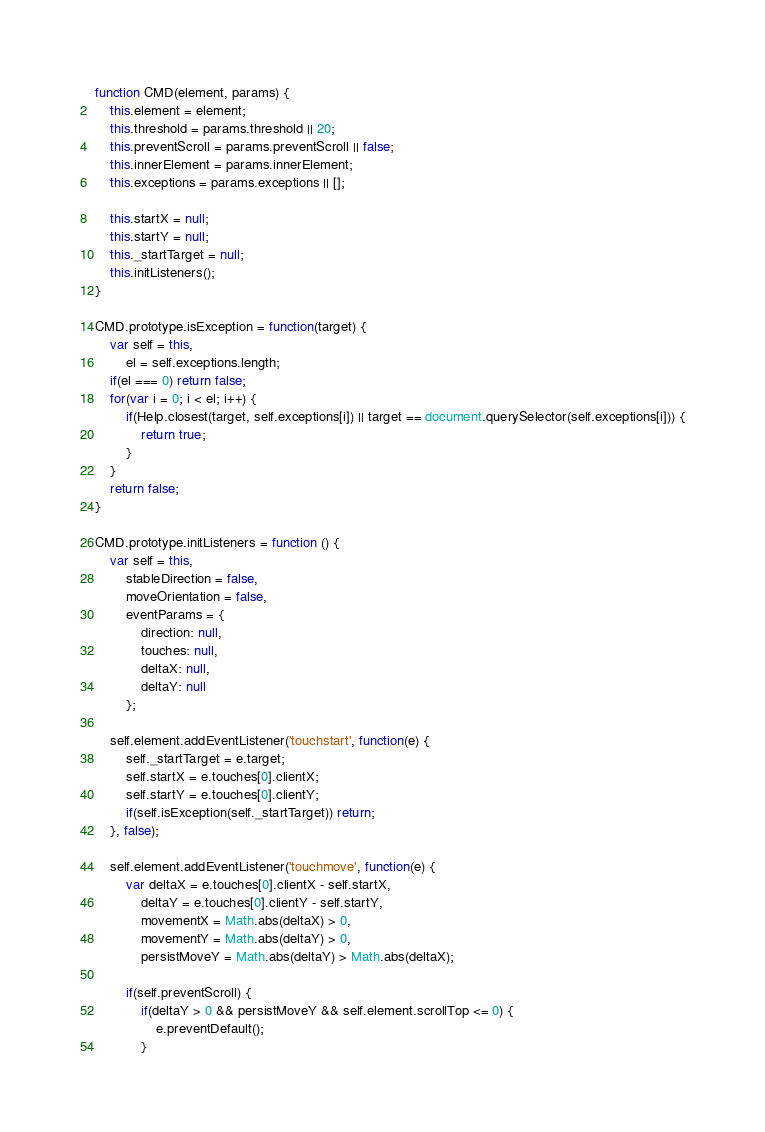<code> <loc_0><loc_0><loc_500><loc_500><_JavaScript_>function CMD(element, params) {
    this.element = element;
    this.threshold = params.threshold || 20;
    this.preventScroll = params.preventScroll || false;
    this.innerElement = params.innerElement;
    this.exceptions = params.exceptions || [];

    this.startX = null;
    this.startY = null;
    this._startTarget = null;
    this.initListeners();
}

CMD.prototype.isException = function(target) {
    var self = this,
        el = self.exceptions.length;
    if(el === 0) return false;
    for(var i = 0; i < el; i++) {
        if(Help.closest(target, self.exceptions[i]) || target == document.querySelector(self.exceptions[i])) {
            return true;
        }
    }
    return false;
}

CMD.prototype.initListeners = function () {
    var self = this,
        stableDirection = false,
        moveOrientation = false,
        eventParams = {
            direction: null,
            touches: null,
            deltaX: null,
            deltaY: null
        };

    self.element.addEventListener('touchstart', function(e) {
        self._startTarget = e.target;
        self.startX = e.touches[0].clientX;
        self.startY = e.touches[0].clientY;
        if(self.isException(self._startTarget)) return;
    }, false);

    self.element.addEventListener('touchmove', function(e) {
        var deltaX = e.touches[0].clientX - self.startX,
            deltaY = e.touches[0].clientY - self.startY,
            movementX = Math.abs(deltaX) > 0,
            movementY = Math.abs(deltaY) > 0,
			persistMoveY = Math.abs(deltaY) > Math.abs(deltaX);

        if(self.preventScroll) {
            if(deltaY > 0 && persistMoveY && self.element.scrollTop <= 0) {
                e.preventDefault();
            }</code> 